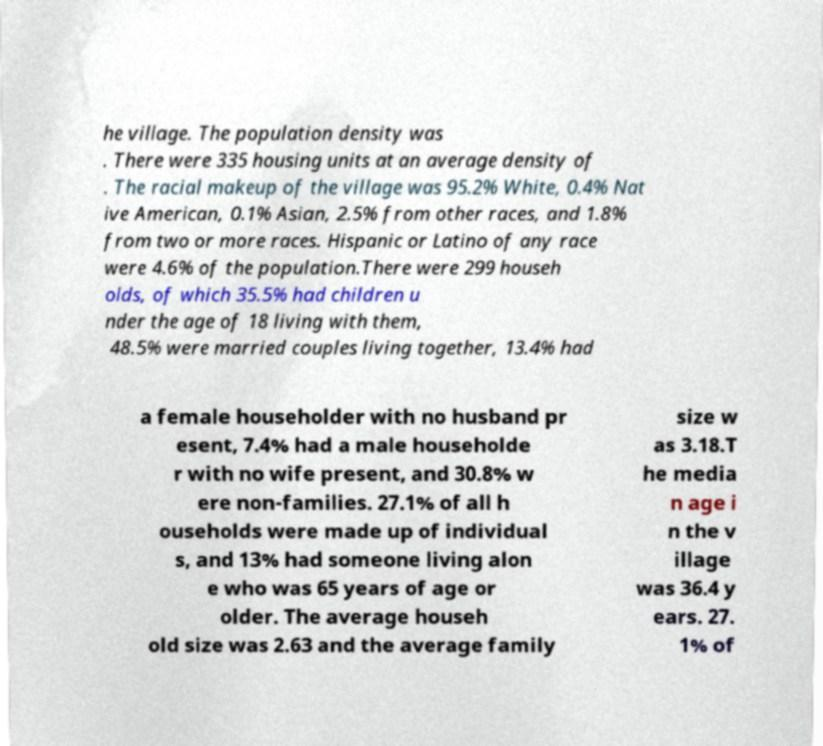Can you read and provide the text displayed in the image?This photo seems to have some interesting text. Can you extract and type it out for me? he village. The population density was . There were 335 housing units at an average density of . The racial makeup of the village was 95.2% White, 0.4% Nat ive American, 0.1% Asian, 2.5% from other races, and 1.8% from two or more races. Hispanic or Latino of any race were 4.6% of the population.There were 299 househ olds, of which 35.5% had children u nder the age of 18 living with them, 48.5% were married couples living together, 13.4% had a female householder with no husband pr esent, 7.4% had a male householde r with no wife present, and 30.8% w ere non-families. 27.1% of all h ouseholds were made up of individual s, and 13% had someone living alon e who was 65 years of age or older. The average househ old size was 2.63 and the average family size w as 3.18.T he media n age i n the v illage was 36.4 y ears. 27. 1% of 